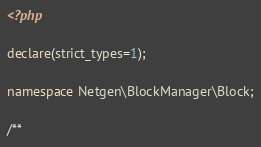<code> <loc_0><loc_0><loc_500><loc_500><_PHP_><?php

declare(strict_types=1);

namespace Netgen\BlockManager\Block;

/**</code> 